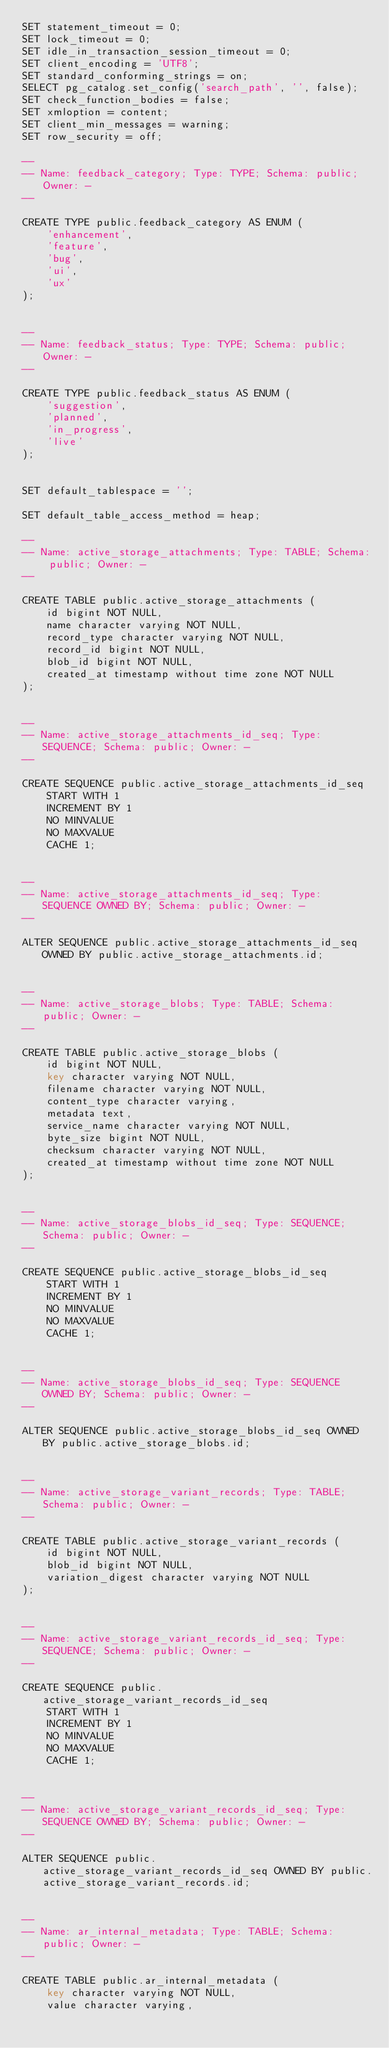Convert code to text. <code><loc_0><loc_0><loc_500><loc_500><_SQL_>SET statement_timeout = 0;
SET lock_timeout = 0;
SET idle_in_transaction_session_timeout = 0;
SET client_encoding = 'UTF8';
SET standard_conforming_strings = on;
SELECT pg_catalog.set_config('search_path', '', false);
SET check_function_bodies = false;
SET xmloption = content;
SET client_min_messages = warning;
SET row_security = off;

--
-- Name: feedback_category; Type: TYPE; Schema: public; Owner: -
--

CREATE TYPE public.feedback_category AS ENUM (
    'enhancement',
    'feature',
    'bug',
    'ui',
    'ux'
);


--
-- Name: feedback_status; Type: TYPE; Schema: public; Owner: -
--

CREATE TYPE public.feedback_status AS ENUM (
    'suggestion',
    'planned',
    'in_progress',
    'live'
);


SET default_tablespace = '';

SET default_table_access_method = heap;

--
-- Name: active_storage_attachments; Type: TABLE; Schema: public; Owner: -
--

CREATE TABLE public.active_storage_attachments (
    id bigint NOT NULL,
    name character varying NOT NULL,
    record_type character varying NOT NULL,
    record_id bigint NOT NULL,
    blob_id bigint NOT NULL,
    created_at timestamp without time zone NOT NULL
);


--
-- Name: active_storage_attachments_id_seq; Type: SEQUENCE; Schema: public; Owner: -
--

CREATE SEQUENCE public.active_storage_attachments_id_seq
    START WITH 1
    INCREMENT BY 1
    NO MINVALUE
    NO MAXVALUE
    CACHE 1;


--
-- Name: active_storage_attachments_id_seq; Type: SEQUENCE OWNED BY; Schema: public; Owner: -
--

ALTER SEQUENCE public.active_storage_attachments_id_seq OWNED BY public.active_storage_attachments.id;


--
-- Name: active_storage_blobs; Type: TABLE; Schema: public; Owner: -
--

CREATE TABLE public.active_storage_blobs (
    id bigint NOT NULL,
    key character varying NOT NULL,
    filename character varying NOT NULL,
    content_type character varying,
    metadata text,
    service_name character varying NOT NULL,
    byte_size bigint NOT NULL,
    checksum character varying NOT NULL,
    created_at timestamp without time zone NOT NULL
);


--
-- Name: active_storage_blobs_id_seq; Type: SEQUENCE; Schema: public; Owner: -
--

CREATE SEQUENCE public.active_storage_blobs_id_seq
    START WITH 1
    INCREMENT BY 1
    NO MINVALUE
    NO MAXVALUE
    CACHE 1;


--
-- Name: active_storage_blobs_id_seq; Type: SEQUENCE OWNED BY; Schema: public; Owner: -
--

ALTER SEQUENCE public.active_storage_blobs_id_seq OWNED BY public.active_storage_blobs.id;


--
-- Name: active_storage_variant_records; Type: TABLE; Schema: public; Owner: -
--

CREATE TABLE public.active_storage_variant_records (
    id bigint NOT NULL,
    blob_id bigint NOT NULL,
    variation_digest character varying NOT NULL
);


--
-- Name: active_storage_variant_records_id_seq; Type: SEQUENCE; Schema: public; Owner: -
--

CREATE SEQUENCE public.active_storage_variant_records_id_seq
    START WITH 1
    INCREMENT BY 1
    NO MINVALUE
    NO MAXVALUE
    CACHE 1;


--
-- Name: active_storage_variant_records_id_seq; Type: SEQUENCE OWNED BY; Schema: public; Owner: -
--

ALTER SEQUENCE public.active_storage_variant_records_id_seq OWNED BY public.active_storage_variant_records.id;


--
-- Name: ar_internal_metadata; Type: TABLE; Schema: public; Owner: -
--

CREATE TABLE public.ar_internal_metadata (
    key character varying NOT NULL,
    value character varying,</code> 